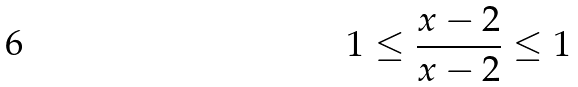<formula> <loc_0><loc_0><loc_500><loc_500>1 \leq \frac { x - 2 } { x - 2 } \leq 1</formula> 